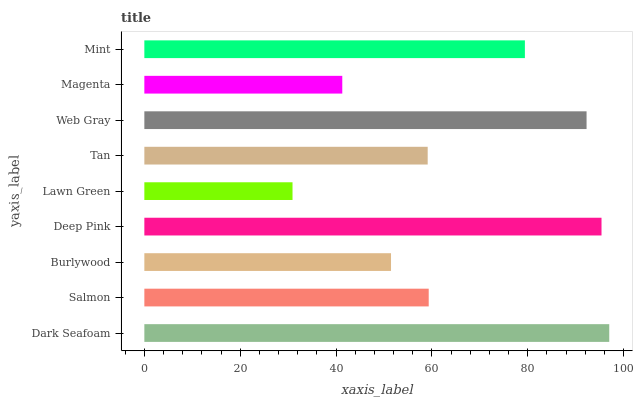Is Lawn Green the minimum?
Answer yes or no. Yes. Is Dark Seafoam the maximum?
Answer yes or no. Yes. Is Salmon the minimum?
Answer yes or no. No. Is Salmon the maximum?
Answer yes or no. No. Is Dark Seafoam greater than Salmon?
Answer yes or no. Yes. Is Salmon less than Dark Seafoam?
Answer yes or no. Yes. Is Salmon greater than Dark Seafoam?
Answer yes or no. No. Is Dark Seafoam less than Salmon?
Answer yes or no. No. Is Salmon the high median?
Answer yes or no. Yes. Is Salmon the low median?
Answer yes or no. Yes. Is Deep Pink the high median?
Answer yes or no. No. Is Burlywood the low median?
Answer yes or no. No. 